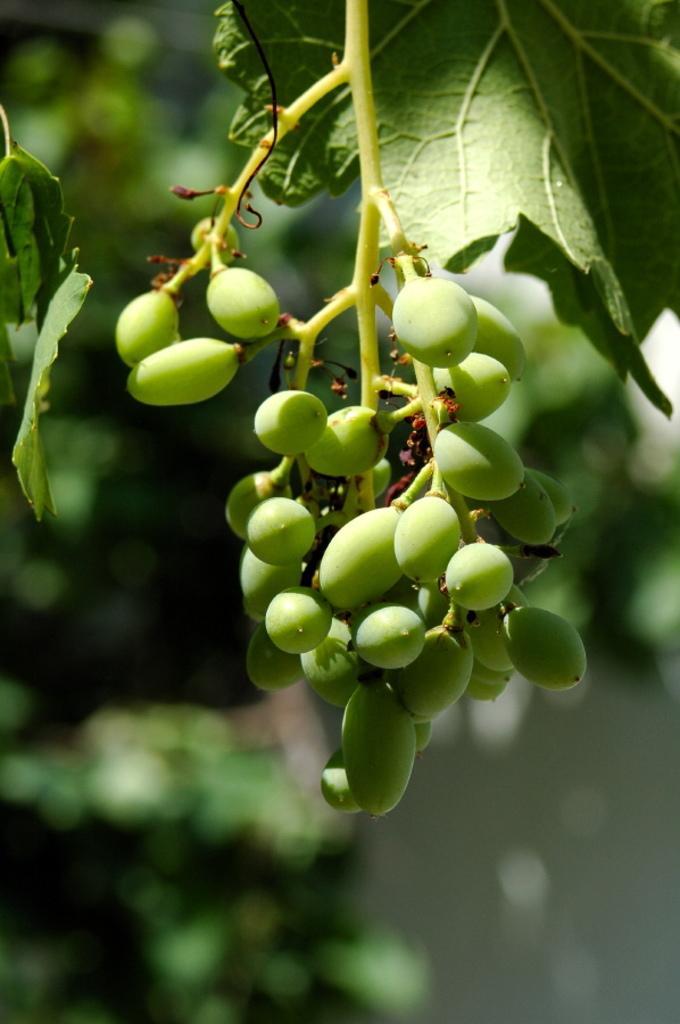How would you summarize this image in a sentence or two? In this image I can see few seeds and plants in green color. 